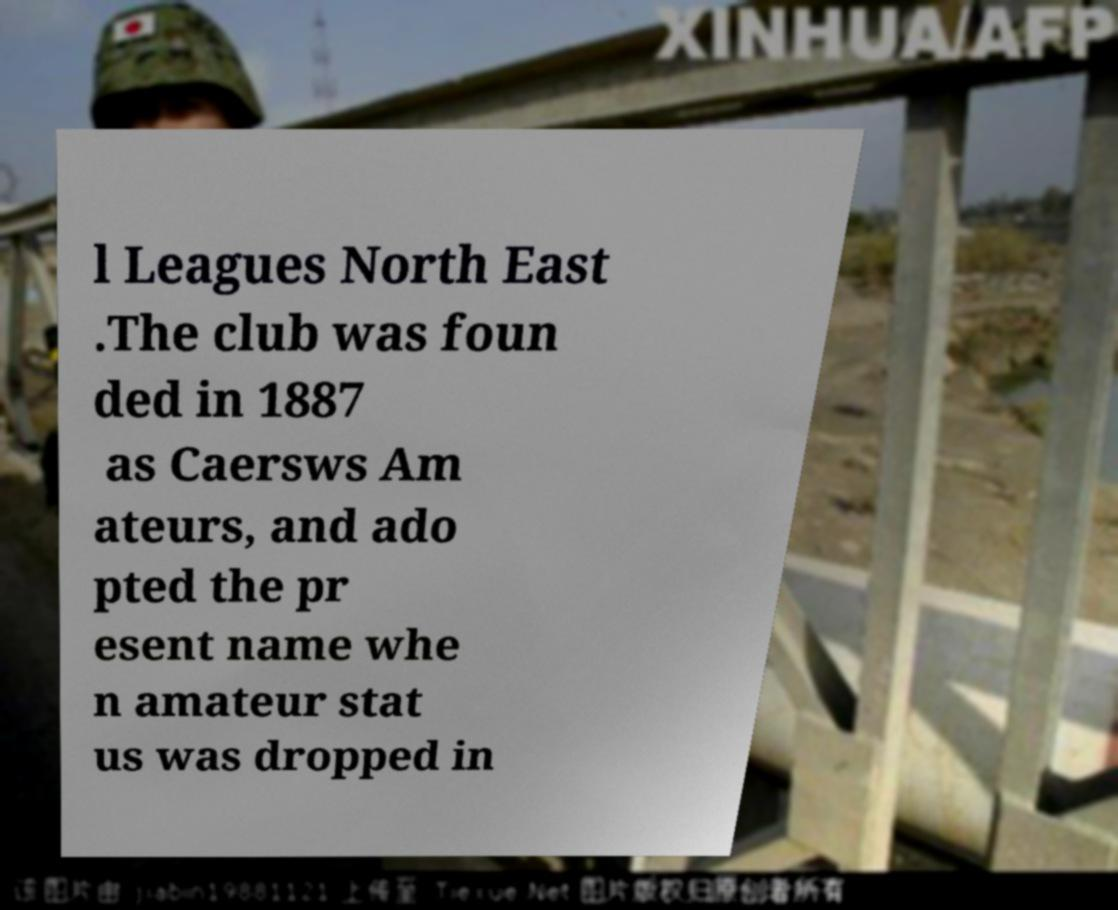Can you accurately transcribe the text from the provided image for me? l Leagues North East .The club was foun ded in 1887 as Caersws Am ateurs, and ado pted the pr esent name whe n amateur stat us was dropped in 